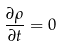<formula> <loc_0><loc_0><loc_500><loc_500>\frac { \partial \rho } { \partial t } = 0</formula> 